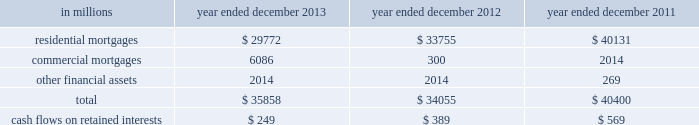Notes to consolidated financial statements note 10 .
Securitization activities the firm securitizes residential and commercial mortgages , corporate bonds , loans and other types of financial assets by selling these assets to securitization vehicles ( e.g. , trusts , corporate entities and limited liability companies ) or through a resecuritization .
The firm acts as underwriter of the beneficial interests that are sold to investors .
The firm 2019s residential mortgage securitizations are substantially all in connection with government agency securitizations .
Beneficial interests issued by securitization entities are debt or equity securities that give the investors rights to receive all or portions of specified cash inflows to a securitization vehicle and include senior and subordinated interests in principal , interest and/or other cash inflows .
The proceeds from the sale of beneficial interests are used to pay the transferor for the financial assets sold to the securitization vehicle or to purchase securities which serve as collateral .
The firm accounts for a securitization as a sale when it has relinquished control over the transferred assets .
Prior to securitization , the firm accounts for assets pending transfer at fair value and therefore does not typically recognize significant gains or losses upon the transfer of assets .
Net revenues from underwriting activities are recognized in connection with the sales of the underlying beneficial interests to investors .
For transfers of assets that are not accounted for as sales , the assets remain in 201cfinancial instruments owned , at fair value 201d and the transfer is accounted for as a collateralized financing , with the related interest expense recognized over the life of the transaction .
See notes 9 and 23 for further information about collateralized financings and interest expense , respectively .
The firm generally receives cash in exchange for the transferred assets but may also have continuing involvement with transferred assets , including ownership of beneficial interests in securitized financial assets , primarily in the form of senior or subordinated securities .
The firm may also purchase senior or subordinated securities issued by securitization vehicles ( which are typically vies ) in connection with secondary market-making activities .
The primary risks included in beneficial interests and other interests from the firm 2019s continuing involvement with securitization vehicles are the performance of the underlying collateral , the position of the firm 2019s investment in the capital structure of the securitization vehicle and the market yield for the security .
These interests are accounted for at fair value and are included in 201cfinancial instruments owned , at fair value 201d and are generally classified in level 2 of the fair value hierarchy .
See notes 5 through 8 for further information about fair value measurements .
The table below presents the amount of financial assets securitized and the cash flows received on retained interests in securitization entities in which the firm had continuing involvement. .
Goldman sachs 2013 annual report 165 .
What percent of financial assets securitized in 2013 were residential mortgages? 
Computations: (29772 / 35858)
Answer: 0.83027. 